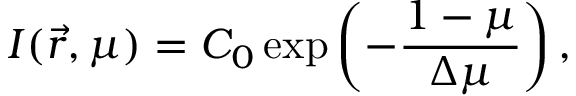<formula> <loc_0><loc_0><loc_500><loc_500>I ( \vec { r } , \mu ) = C _ { 0 } \exp \left ( - \frac { 1 - \mu } { \Delta \mu } \right ) ,</formula> 